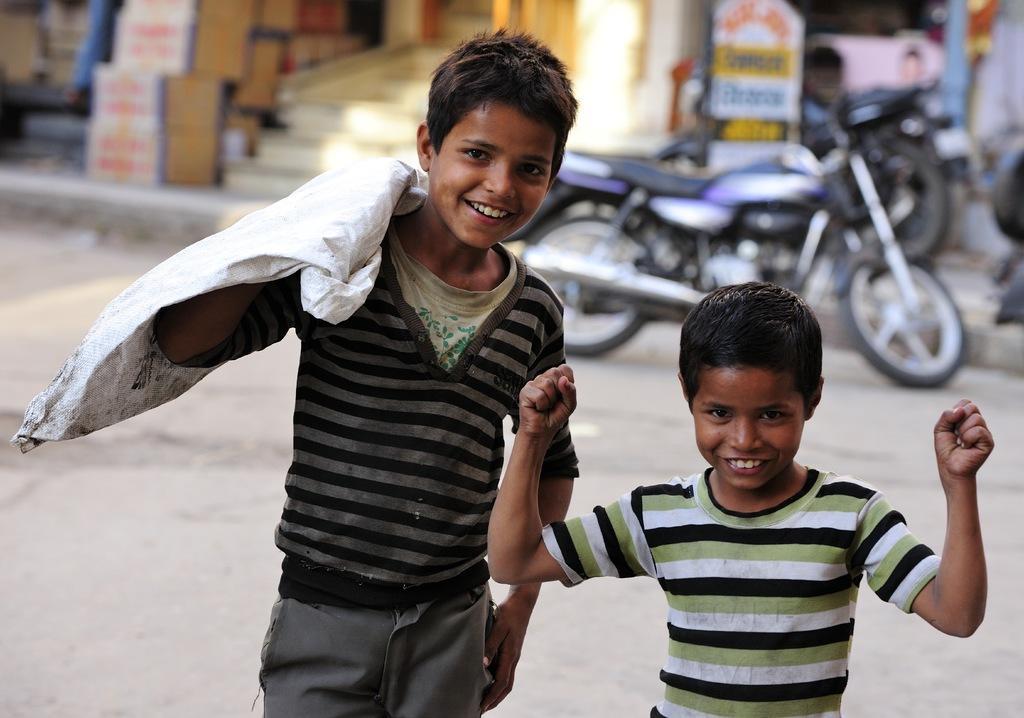Please provide a concise description of this image. Background portion of the picture is blur. We can see the stairs, boxes, a board and motor bikes. We can see two boys standing on the road and smiling. On the left side we can see a man carrying a white bag. 